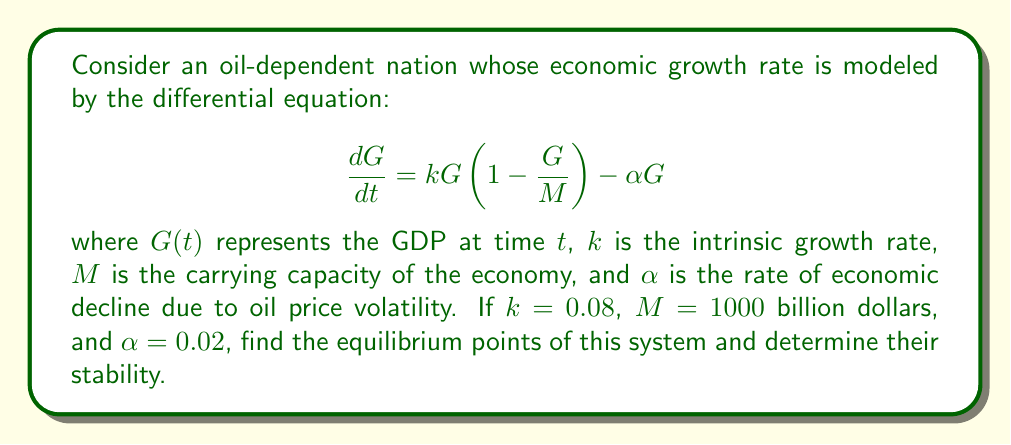Give your solution to this math problem. 1) To find the equilibrium points, we set $\frac{dG}{dt} = 0$:

   $$0 = kG(1 - \frac{G}{M}) - \alpha G$$

2) Factor out $G$:

   $$0 = G(k(1 - \frac{G}{M}) - \alpha)$$

3) Solve for $G$:
   
   Either $G = 0$, or $k(1 - \frac{G}{M}) - \alpha = 0$

4) For the second case:

   $$k - \frac{kG}{M} - \alpha = 0$$
   $$k - \alpha = \frac{kG}{M}$$
   $$G = \frac{M(k - \alpha)}{k}$$

5) Substituting the given values:

   $$G = \frac{1000(0.08 - 0.02)}{0.08} = 750$$

6) To determine stability, we evaluate $\frac{d}{dG}(\frac{dG}{dt})$ at each equilibrium point:

   $$\frac{d}{dG}(\frac{dG}{dt}) = k - \frac{2kG}{M} - \alpha$$

7) At $G = 0$:
   
   $$k - \alpha = 0.08 - 0.02 = 0.06 > 0$$
   
   This is unstable.

8) At $G = 750$:
   
   $$0.08 - \frac{2(0.08)(750)}{1000} - 0.02 = -0.06 < 0$$
   
   This is stable.
Answer: Equilibrium points: $G = 0$ (unstable) and $G = 750$ billion dollars (stable). 